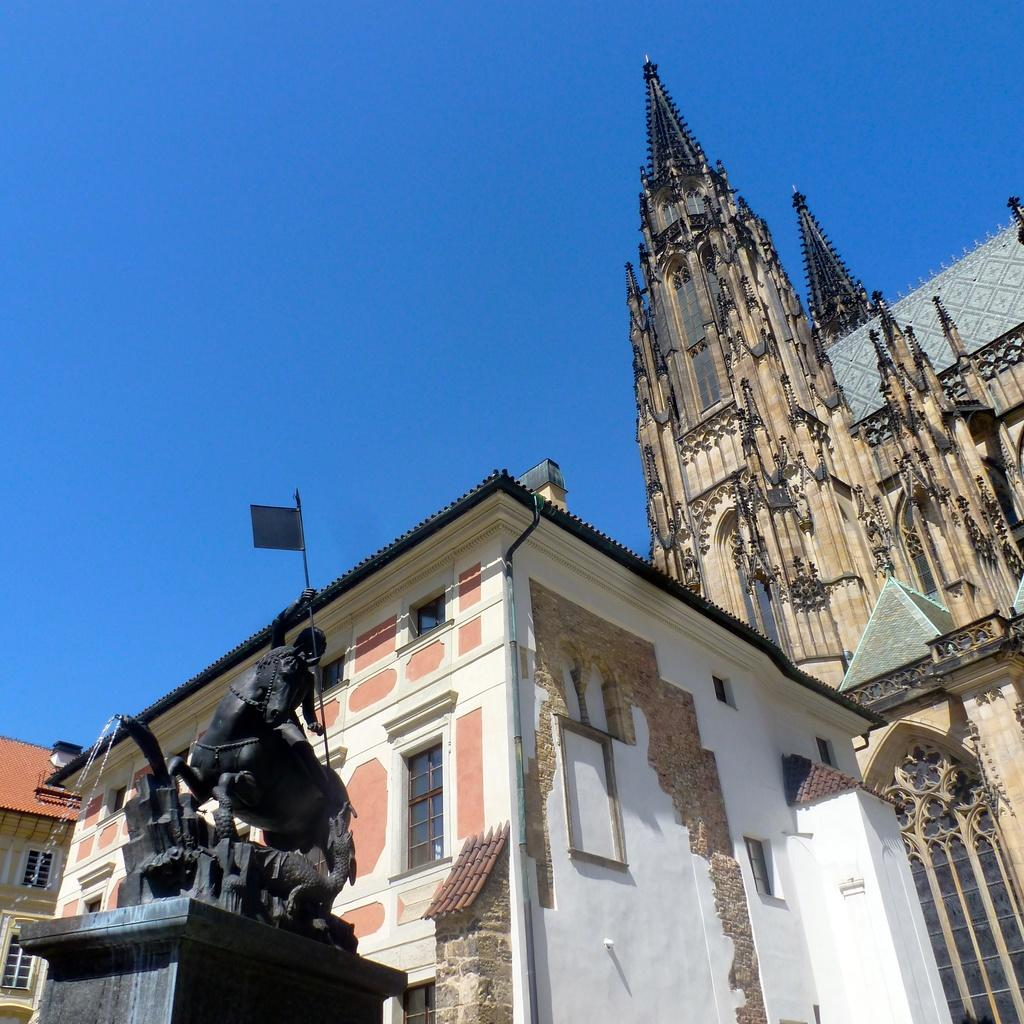What type of structures can be seen in the image? There are buildings in the image. What other object is present in the image besides the buildings? There is a statue in the image. What can be seen in the background of the image? The sky is visible in the image. What type of lipstick is the goldfish wearing in the image? There is no goldfish or lipstick present in the image. 